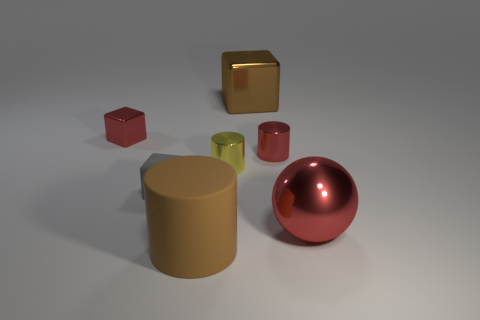Is the ball the same color as the tiny metal cube?
Offer a very short reply. Yes. Does the metallic block left of the large cube have the same color as the large thing right of the large brown metal thing?
Ensure brevity in your answer.  Yes. Does the tiny rubber object have the same shape as the yellow metal object?
Offer a very short reply. No. There is a tiny red metallic object right of the rubber cube; how many yellow shiny cylinders are to the left of it?
Your answer should be compact. 1. There is a big thing that is the same shape as the tiny gray matte object; what material is it?
Your answer should be compact. Metal. Is the color of the metal block that is right of the tiny yellow shiny cylinder the same as the small rubber thing?
Your answer should be compact. No. Is the material of the big ball the same as the tiny cylinder that is to the right of the large brown cube?
Give a very brief answer. Yes. There is a brown thing in front of the big metallic sphere; what is its shape?
Keep it short and to the point. Cylinder. What number of other objects are there of the same material as the brown cylinder?
Provide a succinct answer. 1. The red cylinder is what size?
Keep it short and to the point. Small. 